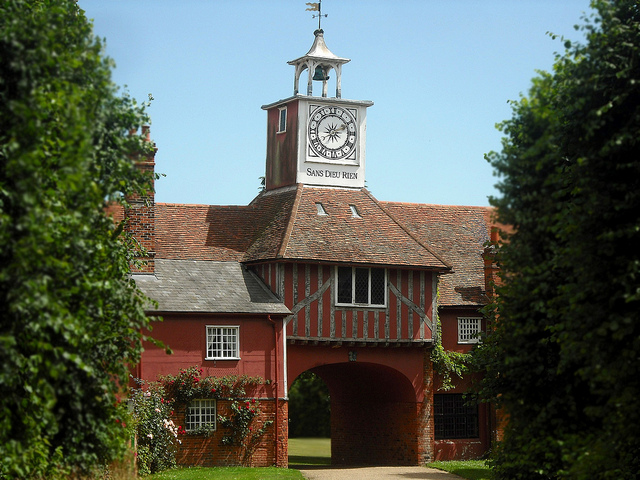Please transcribe the text information in this image. SANS 